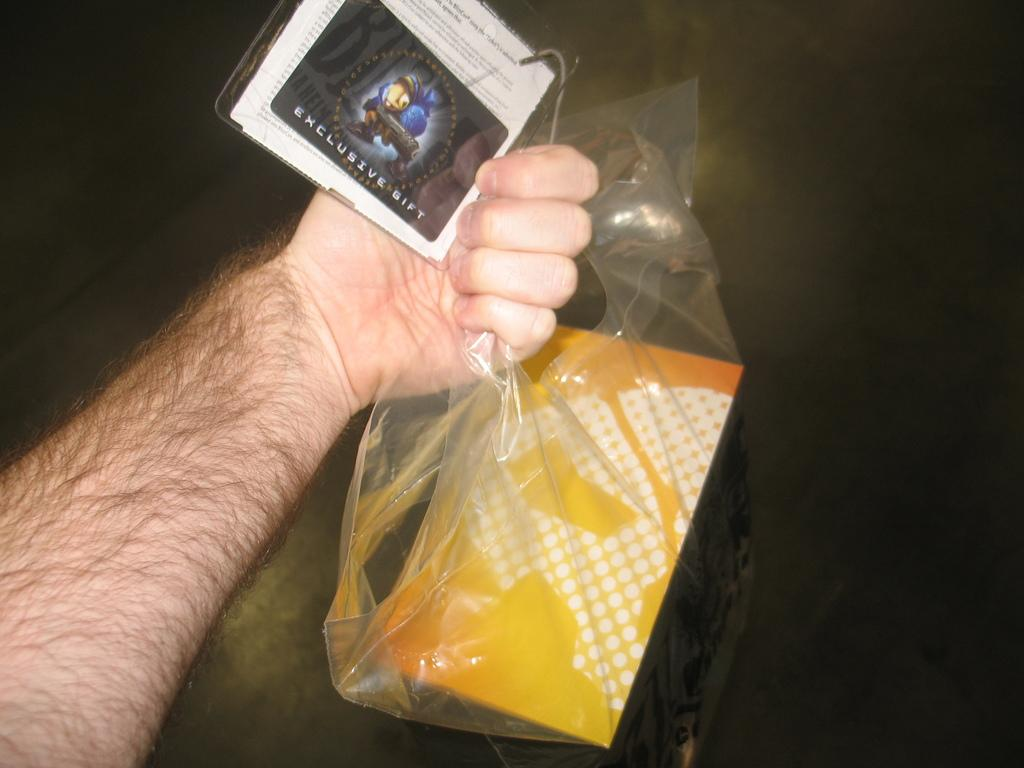What part of a person's body is visible in the image? A person's hand is visible in the image. What is the hand holding? The hand is holding a cover and a card. What is inside the cover? There is an object inside the cover. What can be seen in the background of the image? The background of the image includes a floor. What type of lead can be seen in the image? There is no lead present in the image. 